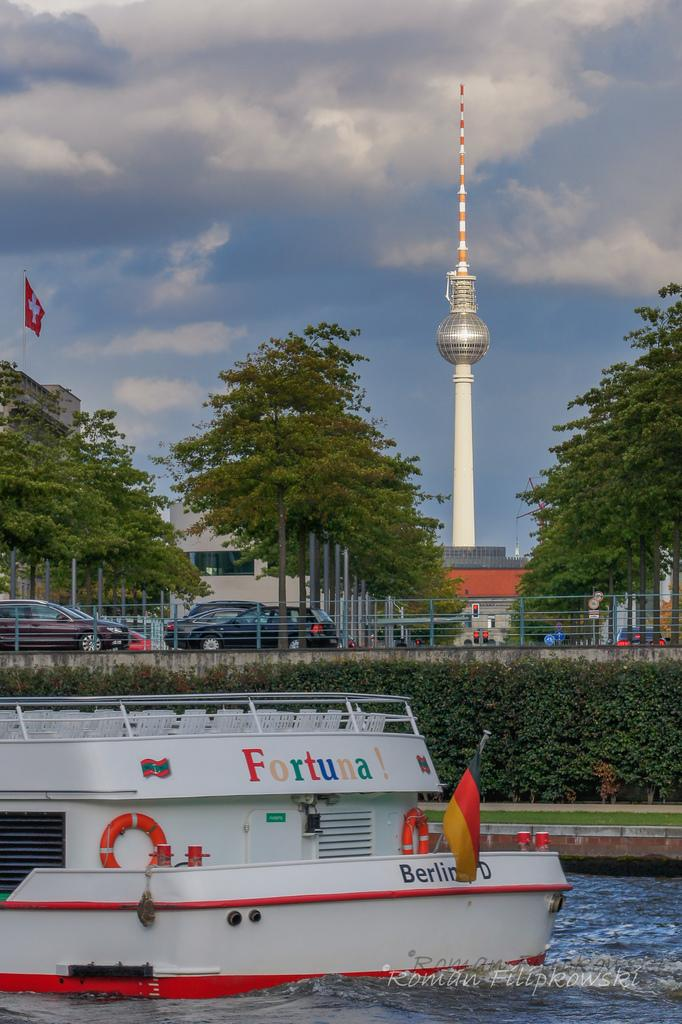<image>
Summarize the visual content of the image. White boat with the words Fortuna on top. 